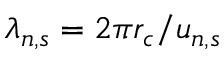<formula> <loc_0><loc_0><loc_500><loc_500>\lambda _ { n , s } = 2 \pi r _ { c } / u _ { n , s }</formula> 